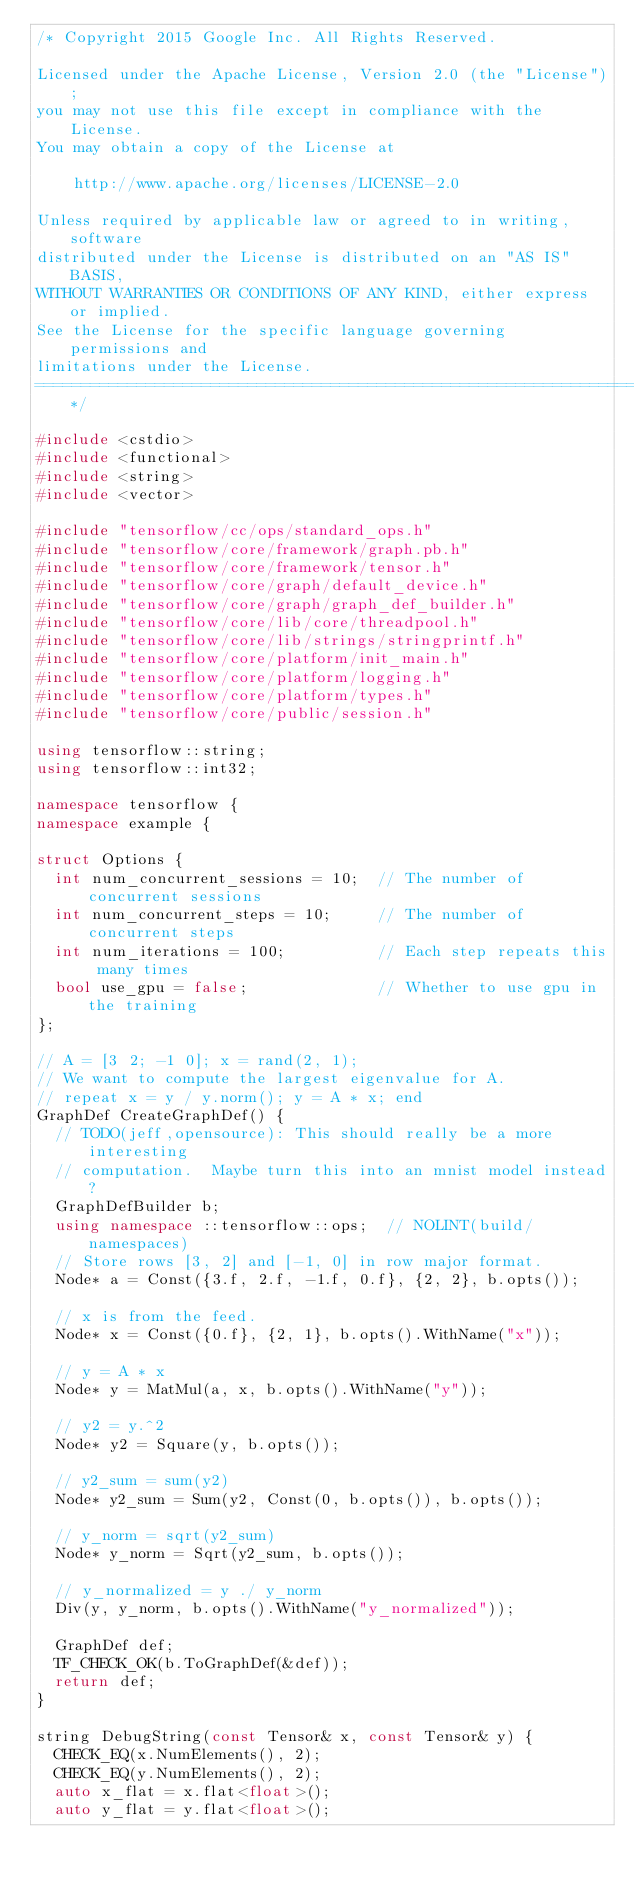<code> <loc_0><loc_0><loc_500><loc_500><_C++_>/* Copyright 2015 Google Inc. All Rights Reserved.

Licensed under the Apache License, Version 2.0 (the "License");
you may not use this file except in compliance with the License.
You may obtain a copy of the License at

    http://www.apache.org/licenses/LICENSE-2.0

Unless required by applicable law or agreed to in writing, software
distributed under the License is distributed on an "AS IS" BASIS,
WITHOUT WARRANTIES OR CONDITIONS OF ANY KIND, either express or implied.
See the License for the specific language governing permissions and
limitations under the License.
==============================================================================*/

#include <cstdio>
#include <functional>
#include <string>
#include <vector>

#include "tensorflow/cc/ops/standard_ops.h"
#include "tensorflow/core/framework/graph.pb.h"
#include "tensorflow/core/framework/tensor.h"
#include "tensorflow/core/graph/default_device.h"
#include "tensorflow/core/graph/graph_def_builder.h"
#include "tensorflow/core/lib/core/threadpool.h"
#include "tensorflow/core/lib/strings/stringprintf.h"
#include "tensorflow/core/platform/init_main.h"
#include "tensorflow/core/platform/logging.h"
#include "tensorflow/core/platform/types.h"
#include "tensorflow/core/public/session.h"

using tensorflow::string;
using tensorflow::int32;

namespace tensorflow {
namespace example {

struct Options {
  int num_concurrent_sessions = 10;  // The number of concurrent sessions
  int num_concurrent_steps = 10;     // The number of concurrent steps
  int num_iterations = 100;          // Each step repeats this many times
  bool use_gpu = false;              // Whether to use gpu in the training
};

// A = [3 2; -1 0]; x = rand(2, 1);
// We want to compute the largest eigenvalue for A.
// repeat x = y / y.norm(); y = A * x; end
GraphDef CreateGraphDef() {
  // TODO(jeff,opensource): This should really be a more interesting
  // computation.  Maybe turn this into an mnist model instead?
  GraphDefBuilder b;
  using namespace ::tensorflow::ops;  // NOLINT(build/namespaces)
  // Store rows [3, 2] and [-1, 0] in row major format.
  Node* a = Const({3.f, 2.f, -1.f, 0.f}, {2, 2}, b.opts());

  // x is from the feed.
  Node* x = Const({0.f}, {2, 1}, b.opts().WithName("x"));

  // y = A * x
  Node* y = MatMul(a, x, b.opts().WithName("y"));

  // y2 = y.^2
  Node* y2 = Square(y, b.opts());

  // y2_sum = sum(y2)
  Node* y2_sum = Sum(y2, Const(0, b.opts()), b.opts());

  // y_norm = sqrt(y2_sum)
  Node* y_norm = Sqrt(y2_sum, b.opts());

  // y_normalized = y ./ y_norm
  Div(y, y_norm, b.opts().WithName("y_normalized"));

  GraphDef def;
  TF_CHECK_OK(b.ToGraphDef(&def));
  return def;
}

string DebugString(const Tensor& x, const Tensor& y) {
  CHECK_EQ(x.NumElements(), 2);
  CHECK_EQ(y.NumElements(), 2);
  auto x_flat = x.flat<float>();
  auto y_flat = y.flat<float>();</code> 